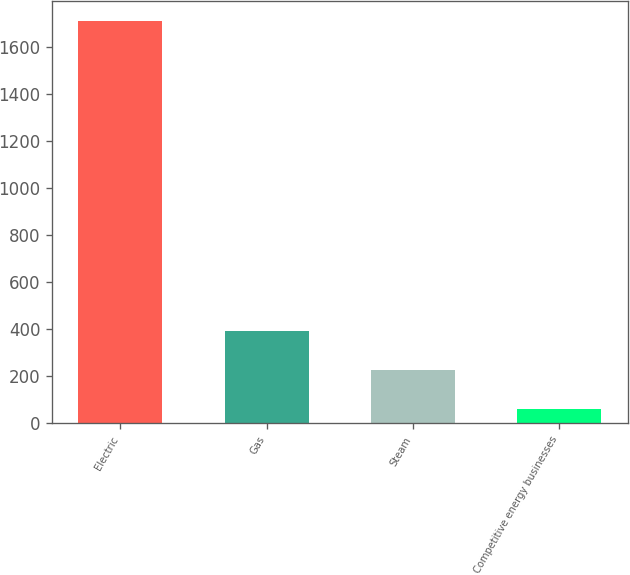<chart> <loc_0><loc_0><loc_500><loc_500><bar_chart><fcel>Electric<fcel>Gas<fcel>Steam<fcel>Competitive energy businesses<nl><fcel>1712<fcel>390.4<fcel>225.2<fcel>60<nl></chart> 